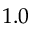Convert formula to latex. <formula><loc_0><loc_0><loc_500><loc_500>1 . 0</formula> 